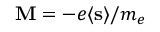<formula> <loc_0><loc_0><loc_500><loc_500>M = - e \langle s \rangle / m _ { e }</formula> 